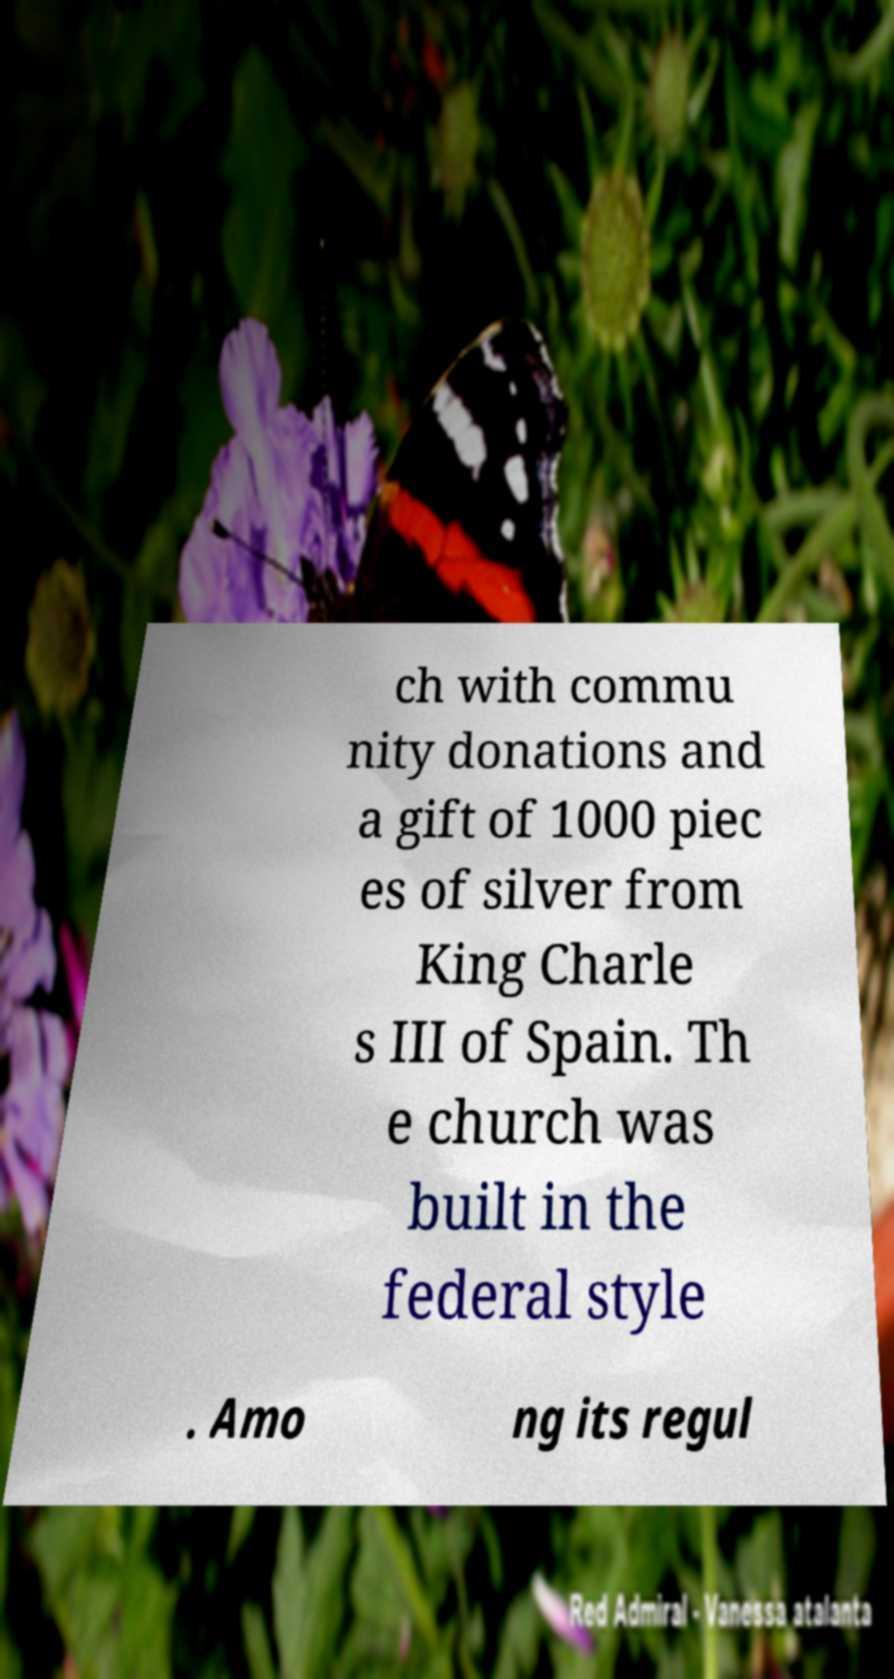Can you accurately transcribe the text from the provided image for me? ch with commu nity donations and a gift of 1000 piec es of silver from King Charle s III of Spain. Th e church was built in the federal style . Amo ng its regul 